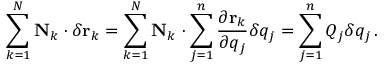Convert formula to latex. <formula><loc_0><loc_0><loc_500><loc_500>\sum _ { k = 1 } ^ { N } N _ { k } \cdot \delta r _ { k } = \sum _ { k = 1 } ^ { N } N _ { k } \cdot \sum _ { j = 1 } ^ { n } { \frac { \partial r _ { k } } { \partial q _ { j } } } \delta q _ { j } = \sum _ { j = 1 } ^ { n } Q _ { j } \delta q _ { j } \, .</formula> 